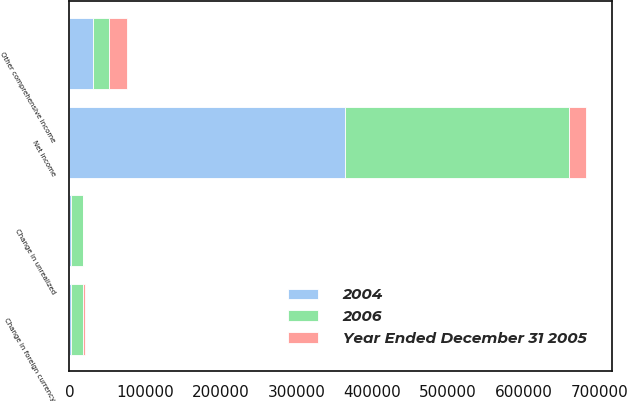Convert chart to OTSL. <chart><loc_0><loc_0><loc_500><loc_500><stacked_bar_chart><ecel><fcel>Net income<fcel>Change in unrealized<fcel>Change in foreign currency<fcel>Other comprehensive income<nl><fcel>Year Ended December 31 2005<fcel>22368<fcel>143<fcel>2503<fcel>23821<nl><fcel>2004<fcel>363628<fcel>2536<fcel>2040<fcel>31265<nl><fcel>2006<fcel>297137<fcel>15102<fcel>15675<fcel>20915<nl></chart> 